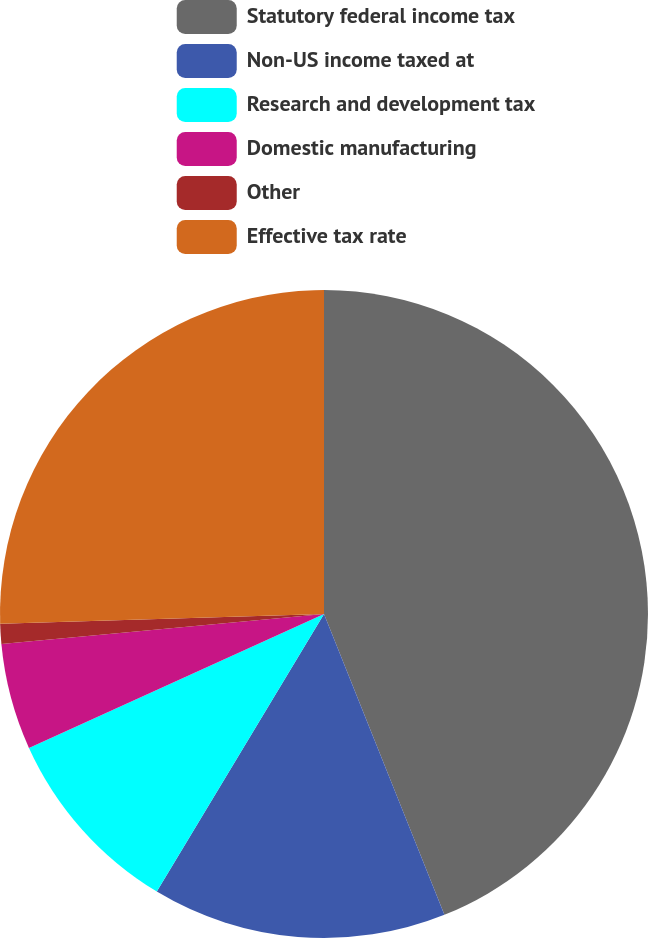<chart> <loc_0><loc_0><loc_500><loc_500><pie_chart><fcel>Statutory federal income tax<fcel>Non-US income taxed at<fcel>Research and development tax<fcel>Domestic manufacturing<fcel>Other<fcel>Effective tax rate<nl><fcel>43.94%<fcel>14.69%<fcel>9.59%<fcel>5.3%<fcel>1.0%<fcel>25.48%<nl></chart> 